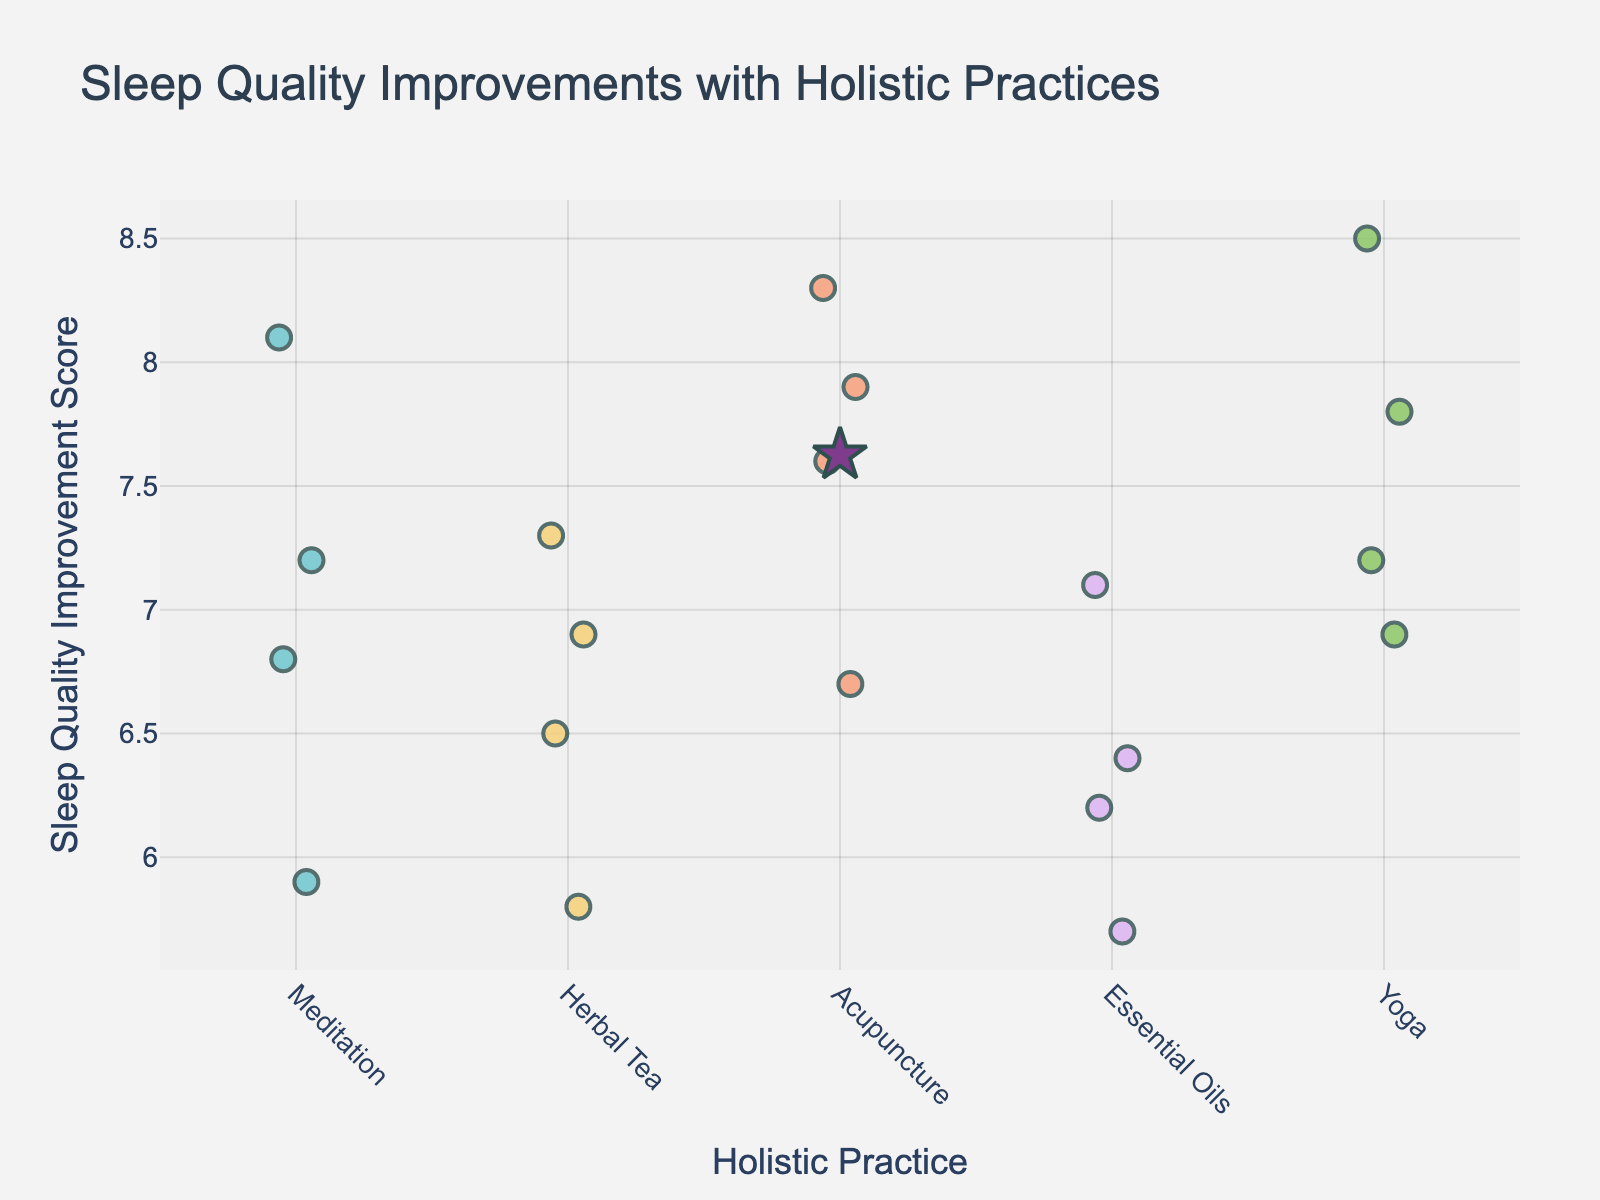What is the title of the plot? Look at the top part of the plot to identify the title text. The title is usually large and prominently placed.
Answer: Sleep Quality Improvements with Holistic Practices How many holistic practices are compared in the plot? Check the x-axis to count the different labels representing the practices. Each label corresponds to a unique holistic practice.
Answer: 5 What holistic practice shows the highest mean sleep quality improvement score? Observe the added star markers that indicate the mean scores for each practice. Compare their positions on the y-axis.
Answer: Acupuncture Which practice has the widest range of sleep quality improvement scores? Identify the ranges by observing the spread of individual data points (dots) along the y-axis for each practice. The practice with the most dispersed points has the widest range.
Answer: Meditation How many data points are there for Yoga? Count the number of dots vertically aligned with the 'Yoga' label on the x-axis. Each dot represents one data point.
Answer: 4 What is the mean sleep quality improvement score for Herbal Tea? Locate the mean star marker for Herbal Tea on the y-axis and note its position.
Answer: Approximately 6.63 How does the sleep quality improvement with Essential Oils compare with Herbal Tea? Compare the positions of the mean star markers for Essential Oils and Herbal Tea along the y-axis to see which is higher.
Answer: Essential Oils is lower What is the median sleep quality improvement score for Acupuncture? Arrange the Acupuncture scores from lowest to highest (6.7, 7.6, 7.9, 8.3) and find the middle value(s). The median is the average of the two middle values (7.6 and 7.9).
Answer: 7.75 Which holistic practice has the most consistent sleep quality improvement scores? Look for the practice where the points are least spread out along the y-axis, indicating low variation.
Answer: Herbal Tea Are there any holistic practices where all scores are above 7? Check the vertical position of all dots for each practice. Note if any of the practices have all dots positioned above the 7 mark on the y-axis.
Answer: No 